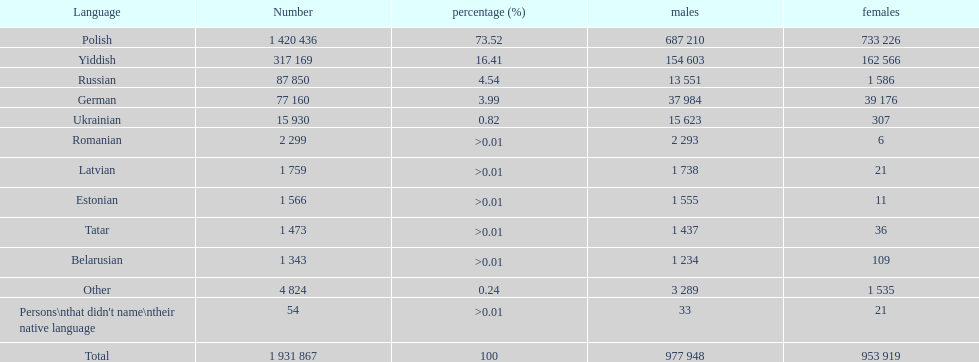What was the next most commonly spoken language in poland after russian? German. 